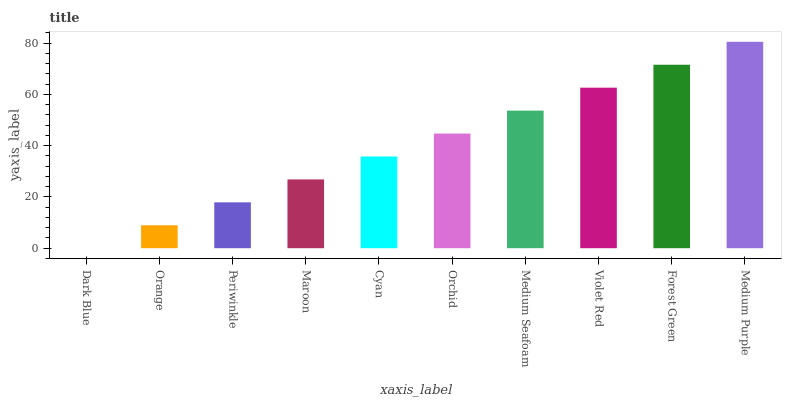Is Orange the minimum?
Answer yes or no. No. Is Orange the maximum?
Answer yes or no. No. Is Orange greater than Dark Blue?
Answer yes or no. Yes. Is Dark Blue less than Orange?
Answer yes or no. Yes. Is Dark Blue greater than Orange?
Answer yes or no. No. Is Orange less than Dark Blue?
Answer yes or no. No. Is Orchid the high median?
Answer yes or no. Yes. Is Cyan the low median?
Answer yes or no. Yes. Is Medium Purple the high median?
Answer yes or no. No. Is Periwinkle the low median?
Answer yes or no. No. 